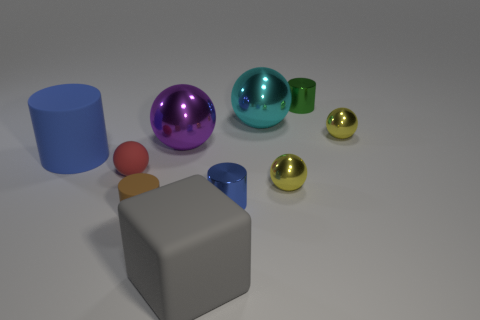How many objects are either tiny shiny objects that are in front of the tiny green metallic object or matte objects to the left of the large purple object?
Keep it short and to the point. 6. Are there the same number of big gray things behind the green thing and large gray spheres?
Offer a very short reply. Yes. There is a blue thing in front of the big blue rubber thing; is its size the same as the rubber thing behind the small red rubber object?
Keep it short and to the point. No. What number of other objects are there of the same size as the green cylinder?
Your answer should be very brief. 5. There is a big purple thing that is behind the large rubber thing that is left of the matte cube; are there any big cubes that are to the right of it?
Provide a succinct answer. Yes. Is there any other thing of the same color as the large cylinder?
Your response must be concise. Yes. There is a blue thing right of the small brown cylinder; how big is it?
Give a very brief answer. Small. How big is the metallic cylinder that is behind the ball that is behind the yellow ball behind the big purple sphere?
Ensure brevity in your answer.  Small. There is a big object that is to the right of the matte block that is in front of the brown rubber object; what is its color?
Give a very brief answer. Cyan. What material is the small red object that is the same shape as the large cyan object?
Your answer should be very brief. Rubber. 